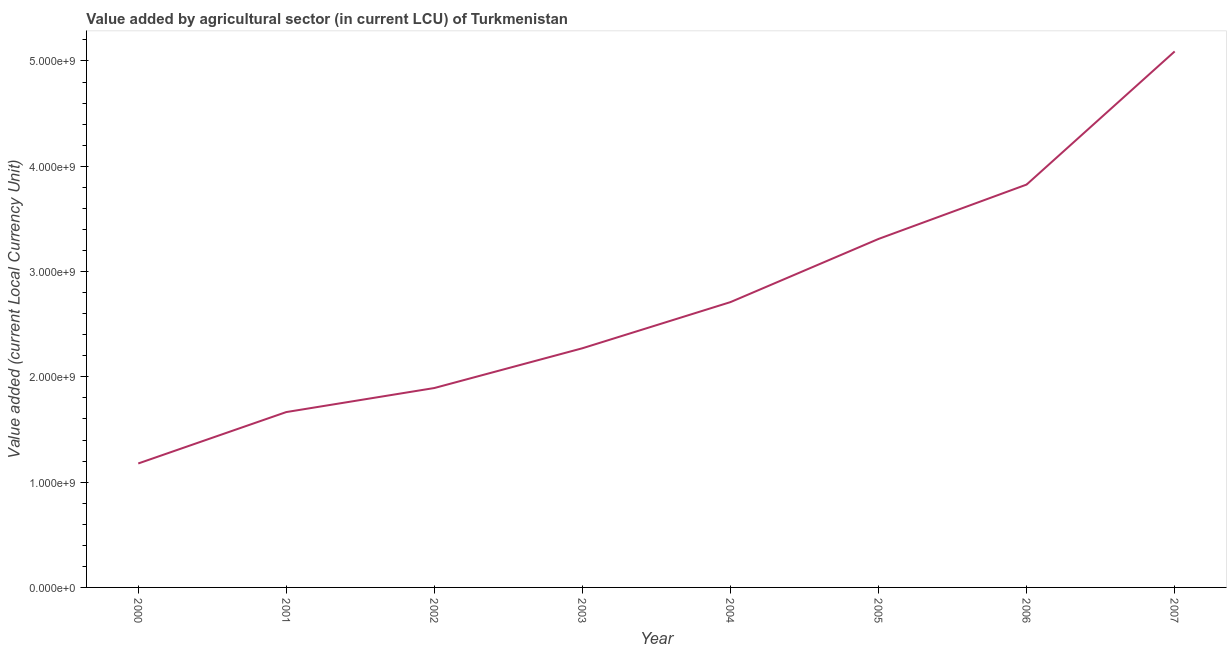What is the value added by agriculture sector in 2006?
Ensure brevity in your answer.  3.83e+09. Across all years, what is the maximum value added by agriculture sector?
Your response must be concise. 5.09e+09. Across all years, what is the minimum value added by agriculture sector?
Ensure brevity in your answer.  1.18e+09. In which year was the value added by agriculture sector maximum?
Make the answer very short. 2007. What is the sum of the value added by agriculture sector?
Make the answer very short. 2.19e+1. What is the difference between the value added by agriculture sector in 2001 and 2005?
Ensure brevity in your answer.  -1.64e+09. What is the average value added by agriculture sector per year?
Keep it short and to the point. 2.74e+09. What is the median value added by agriculture sector?
Provide a succinct answer. 2.49e+09. What is the ratio of the value added by agriculture sector in 2001 to that in 2004?
Make the answer very short. 0.61. Is the value added by agriculture sector in 2001 less than that in 2003?
Your response must be concise. Yes. What is the difference between the highest and the second highest value added by agriculture sector?
Ensure brevity in your answer.  1.26e+09. What is the difference between the highest and the lowest value added by agriculture sector?
Your response must be concise. 3.91e+09. How many years are there in the graph?
Offer a very short reply. 8. What is the difference between two consecutive major ticks on the Y-axis?
Offer a very short reply. 1.00e+09. Are the values on the major ticks of Y-axis written in scientific E-notation?
Your answer should be compact. Yes. Does the graph contain any zero values?
Offer a very short reply. No. What is the title of the graph?
Give a very brief answer. Value added by agricultural sector (in current LCU) of Turkmenistan. What is the label or title of the Y-axis?
Give a very brief answer. Value added (current Local Currency Unit). What is the Value added (current Local Currency Unit) of 2000?
Make the answer very short. 1.18e+09. What is the Value added (current Local Currency Unit) in 2001?
Make the answer very short. 1.67e+09. What is the Value added (current Local Currency Unit) in 2002?
Offer a terse response. 1.89e+09. What is the Value added (current Local Currency Unit) of 2003?
Make the answer very short. 2.27e+09. What is the Value added (current Local Currency Unit) of 2004?
Provide a succinct answer. 2.71e+09. What is the Value added (current Local Currency Unit) in 2005?
Keep it short and to the point. 3.31e+09. What is the Value added (current Local Currency Unit) of 2006?
Offer a very short reply. 3.83e+09. What is the Value added (current Local Currency Unit) in 2007?
Make the answer very short. 5.09e+09. What is the difference between the Value added (current Local Currency Unit) in 2000 and 2001?
Provide a succinct answer. -4.88e+08. What is the difference between the Value added (current Local Currency Unit) in 2000 and 2002?
Provide a short and direct response. -7.17e+08. What is the difference between the Value added (current Local Currency Unit) in 2000 and 2003?
Make the answer very short. -1.09e+09. What is the difference between the Value added (current Local Currency Unit) in 2000 and 2004?
Offer a very short reply. -1.53e+09. What is the difference between the Value added (current Local Currency Unit) in 2000 and 2005?
Ensure brevity in your answer.  -2.13e+09. What is the difference between the Value added (current Local Currency Unit) in 2000 and 2006?
Your answer should be compact. -2.65e+09. What is the difference between the Value added (current Local Currency Unit) in 2000 and 2007?
Make the answer very short. -3.91e+09. What is the difference between the Value added (current Local Currency Unit) in 2001 and 2002?
Give a very brief answer. -2.28e+08. What is the difference between the Value added (current Local Currency Unit) in 2001 and 2003?
Make the answer very short. -6.06e+08. What is the difference between the Value added (current Local Currency Unit) in 2001 and 2004?
Make the answer very short. -1.04e+09. What is the difference between the Value added (current Local Currency Unit) in 2001 and 2005?
Ensure brevity in your answer.  -1.64e+09. What is the difference between the Value added (current Local Currency Unit) in 2001 and 2006?
Your answer should be very brief. -2.16e+09. What is the difference between the Value added (current Local Currency Unit) in 2001 and 2007?
Your answer should be very brief. -3.43e+09. What is the difference between the Value added (current Local Currency Unit) in 2002 and 2003?
Ensure brevity in your answer.  -3.78e+08. What is the difference between the Value added (current Local Currency Unit) in 2002 and 2004?
Provide a short and direct response. -8.16e+08. What is the difference between the Value added (current Local Currency Unit) in 2002 and 2005?
Provide a succinct answer. -1.42e+09. What is the difference between the Value added (current Local Currency Unit) in 2002 and 2006?
Give a very brief answer. -1.93e+09. What is the difference between the Value added (current Local Currency Unit) in 2002 and 2007?
Provide a succinct answer. -3.20e+09. What is the difference between the Value added (current Local Currency Unit) in 2003 and 2004?
Give a very brief answer. -4.38e+08. What is the difference between the Value added (current Local Currency Unit) in 2003 and 2005?
Your answer should be compact. -1.04e+09. What is the difference between the Value added (current Local Currency Unit) in 2003 and 2006?
Your answer should be compact. -1.55e+09. What is the difference between the Value added (current Local Currency Unit) in 2003 and 2007?
Your answer should be compact. -2.82e+09. What is the difference between the Value added (current Local Currency Unit) in 2004 and 2005?
Offer a terse response. -6.00e+08. What is the difference between the Value added (current Local Currency Unit) in 2004 and 2006?
Your answer should be compact. -1.12e+09. What is the difference between the Value added (current Local Currency Unit) in 2004 and 2007?
Provide a short and direct response. -2.38e+09. What is the difference between the Value added (current Local Currency Unit) in 2005 and 2006?
Make the answer very short. -5.16e+08. What is the difference between the Value added (current Local Currency Unit) in 2005 and 2007?
Offer a terse response. -1.78e+09. What is the difference between the Value added (current Local Currency Unit) in 2006 and 2007?
Provide a succinct answer. -1.26e+09. What is the ratio of the Value added (current Local Currency Unit) in 2000 to that in 2001?
Your answer should be compact. 0.71. What is the ratio of the Value added (current Local Currency Unit) in 2000 to that in 2002?
Offer a terse response. 0.62. What is the ratio of the Value added (current Local Currency Unit) in 2000 to that in 2003?
Offer a terse response. 0.52. What is the ratio of the Value added (current Local Currency Unit) in 2000 to that in 2004?
Your response must be concise. 0.43. What is the ratio of the Value added (current Local Currency Unit) in 2000 to that in 2005?
Your response must be concise. 0.36. What is the ratio of the Value added (current Local Currency Unit) in 2000 to that in 2006?
Give a very brief answer. 0.31. What is the ratio of the Value added (current Local Currency Unit) in 2000 to that in 2007?
Provide a short and direct response. 0.23. What is the ratio of the Value added (current Local Currency Unit) in 2001 to that in 2002?
Keep it short and to the point. 0.88. What is the ratio of the Value added (current Local Currency Unit) in 2001 to that in 2003?
Make the answer very short. 0.73. What is the ratio of the Value added (current Local Currency Unit) in 2001 to that in 2004?
Offer a terse response. 0.61. What is the ratio of the Value added (current Local Currency Unit) in 2001 to that in 2005?
Provide a succinct answer. 0.5. What is the ratio of the Value added (current Local Currency Unit) in 2001 to that in 2006?
Offer a terse response. 0.43. What is the ratio of the Value added (current Local Currency Unit) in 2001 to that in 2007?
Provide a short and direct response. 0.33. What is the ratio of the Value added (current Local Currency Unit) in 2002 to that in 2003?
Ensure brevity in your answer.  0.83. What is the ratio of the Value added (current Local Currency Unit) in 2002 to that in 2004?
Your response must be concise. 0.7. What is the ratio of the Value added (current Local Currency Unit) in 2002 to that in 2005?
Your answer should be very brief. 0.57. What is the ratio of the Value added (current Local Currency Unit) in 2002 to that in 2006?
Provide a short and direct response. 0.49. What is the ratio of the Value added (current Local Currency Unit) in 2002 to that in 2007?
Offer a terse response. 0.37. What is the ratio of the Value added (current Local Currency Unit) in 2003 to that in 2004?
Your answer should be compact. 0.84. What is the ratio of the Value added (current Local Currency Unit) in 2003 to that in 2005?
Offer a very short reply. 0.69. What is the ratio of the Value added (current Local Currency Unit) in 2003 to that in 2006?
Your answer should be very brief. 0.59. What is the ratio of the Value added (current Local Currency Unit) in 2003 to that in 2007?
Give a very brief answer. 0.45. What is the ratio of the Value added (current Local Currency Unit) in 2004 to that in 2005?
Your answer should be compact. 0.82. What is the ratio of the Value added (current Local Currency Unit) in 2004 to that in 2006?
Offer a very short reply. 0.71. What is the ratio of the Value added (current Local Currency Unit) in 2004 to that in 2007?
Your response must be concise. 0.53. What is the ratio of the Value added (current Local Currency Unit) in 2005 to that in 2006?
Provide a succinct answer. 0.86. What is the ratio of the Value added (current Local Currency Unit) in 2005 to that in 2007?
Make the answer very short. 0.65. What is the ratio of the Value added (current Local Currency Unit) in 2006 to that in 2007?
Your answer should be very brief. 0.75. 